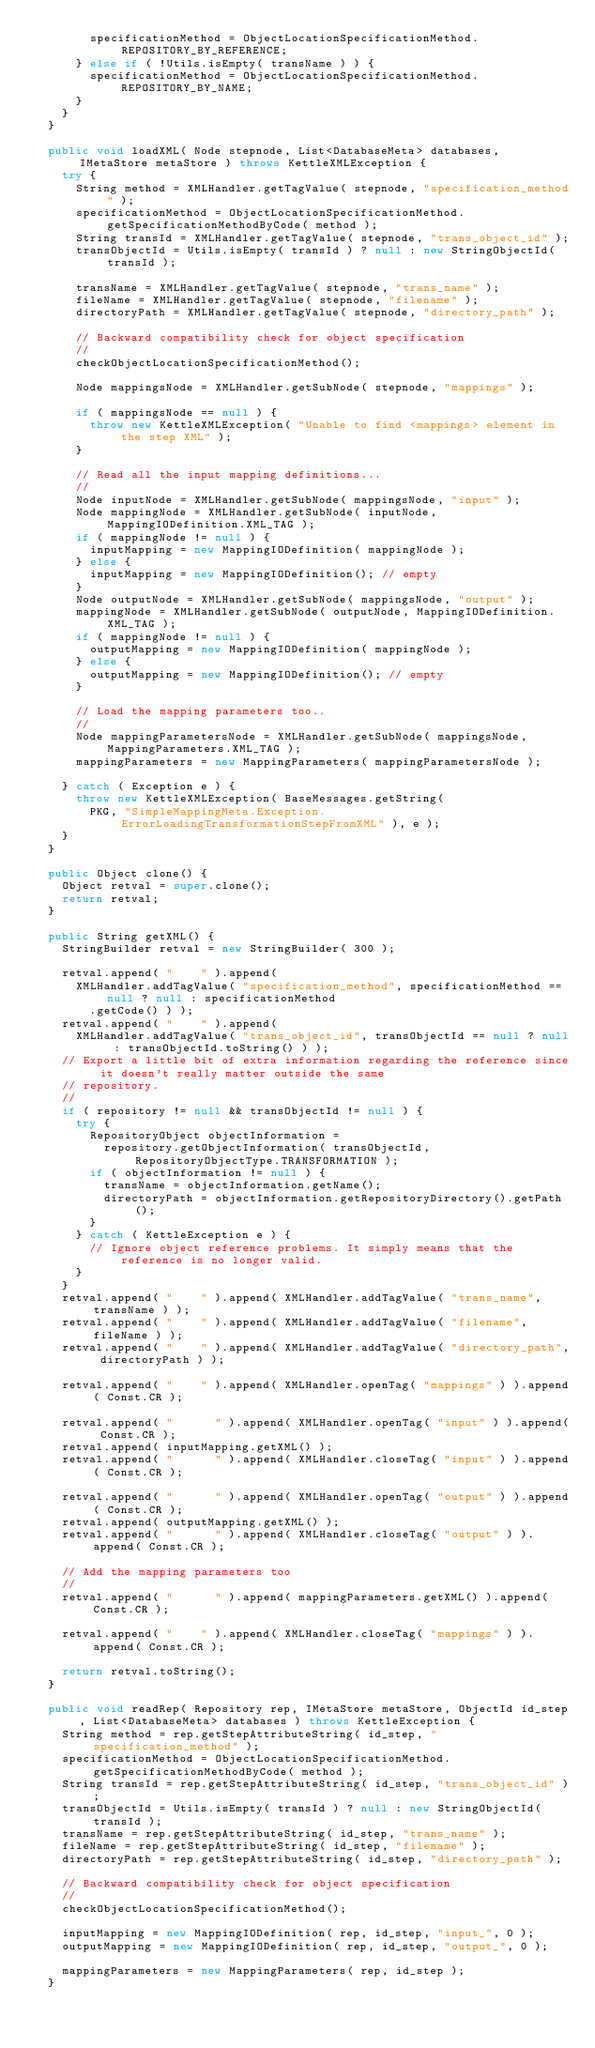Convert code to text. <code><loc_0><loc_0><loc_500><loc_500><_Java_>        specificationMethod = ObjectLocationSpecificationMethod.REPOSITORY_BY_REFERENCE;
      } else if ( !Utils.isEmpty( transName ) ) {
        specificationMethod = ObjectLocationSpecificationMethod.REPOSITORY_BY_NAME;
      }
    }
  }

  public void loadXML( Node stepnode, List<DatabaseMeta> databases, IMetaStore metaStore ) throws KettleXMLException {
    try {
      String method = XMLHandler.getTagValue( stepnode, "specification_method" );
      specificationMethod = ObjectLocationSpecificationMethod.getSpecificationMethodByCode( method );
      String transId = XMLHandler.getTagValue( stepnode, "trans_object_id" );
      transObjectId = Utils.isEmpty( transId ) ? null : new StringObjectId( transId );

      transName = XMLHandler.getTagValue( stepnode, "trans_name" );
      fileName = XMLHandler.getTagValue( stepnode, "filename" );
      directoryPath = XMLHandler.getTagValue( stepnode, "directory_path" );

      // Backward compatibility check for object specification
      //
      checkObjectLocationSpecificationMethod();

      Node mappingsNode = XMLHandler.getSubNode( stepnode, "mappings" );

      if ( mappingsNode == null ) {
        throw new KettleXMLException( "Unable to find <mappings> element in the step XML" );
      }

      // Read all the input mapping definitions...
      //
      Node inputNode = XMLHandler.getSubNode( mappingsNode, "input" );
      Node mappingNode = XMLHandler.getSubNode( inputNode, MappingIODefinition.XML_TAG );
      if ( mappingNode != null ) {
        inputMapping = new MappingIODefinition( mappingNode );
      } else {
        inputMapping = new MappingIODefinition(); // empty
      }
      Node outputNode = XMLHandler.getSubNode( mappingsNode, "output" );
      mappingNode = XMLHandler.getSubNode( outputNode, MappingIODefinition.XML_TAG );
      if ( mappingNode != null ) {
        outputMapping = new MappingIODefinition( mappingNode );
      } else {
        outputMapping = new MappingIODefinition(); // empty
      }

      // Load the mapping parameters too..
      //
      Node mappingParametersNode = XMLHandler.getSubNode( mappingsNode, MappingParameters.XML_TAG );
      mappingParameters = new MappingParameters( mappingParametersNode );

    } catch ( Exception e ) {
      throw new KettleXMLException( BaseMessages.getString(
        PKG, "SimpleMappingMeta.Exception.ErrorLoadingTransformationStepFromXML" ), e );
    }
  }

  public Object clone() {
    Object retval = super.clone();
    return retval;
  }

  public String getXML() {
    StringBuilder retval = new StringBuilder( 300 );

    retval.append( "    " ).append(
      XMLHandler.addTagValue( "specification_method", specificationMethod == null ? null : specificationMethod
        .getCode() ) );
    retval.append( "    " ).append(
      XMLHandler.addTagValue( "trans_object_id", transObjectId == null ? null : transObjectId.toString() ) );
    // Export a little bit of extra information regarding the reference since it doesn't really matter outside the same
    // repository.
    //
    if ( repository != null && transObjectId != null ) {
      try {
        RepositoryObject objectInformation =
          repository.getObjectInformation( transObjectId, RepositoryObjectType.TRANSFORMATION );
        if ( objectInformation != null ) {
          transName = objectInformation.getName();
          directoryPath = objectInformation.getRepositoryDirectory().getPath();
        }
      } catch ( KettleException e ) {
        // Ignore object reference problems. It simply means that the reference is no longer valid.
      }
    }
    retval.append( "    " ).append( XMLHandler.addTagValue( "trans_name", transName ) );
    retval.append( "    " ).append( XMLHandler.addTagValue( "filename", fileName ) );
    retval.append( "    " ).append( XMLHandler.addTagValue( "directory_path", directoryPath ) );

    retval.append( "    " ).append( XMLHandler.openTag( "mappings" ) ).append( Const.CR );

    retval.append( "      " ).append( XMLHandler.openTag( "input" ) ).append( Const.CR );
    retval.append( inputMapping.getXML() );
    retval.append( "      " ).append( XMLHandler.closeTag( "input" ) ).append( Const.CR );

    retval.append( "      " ).append( XMLHandler.openTag( "output" ) ).append( Const.CR );
    retval.append( outputMapping.getXML() );
    retval.append( "      " ).append( XMLHandler.closeTag( "output" ) ).append( Const.CR );

    // Add the mapping parameters too
    //
    retval.append( "      " ).append( mappingParameters.getXML() ).append( Const.CR );

    retval.append( "    " ).append( XMLHandler.closeTag( "mappings" ) ).append( Const.CR );

    return retval.toString();
  }

  public void readRep( Repository rep, IMetaStore metaStore, ObjectId id_step, List<DatabaseMeta> databases ) throws KettleException {
    String method = rep.getStepAttributeString( id_step, "specification_method" );
    specificationMethod = ObjectLocationSpecificationMethod.getSpecificationMethodByCode( method );
    String transId = rep.getStepAttributeString( id_step, "trans_object_id" );
    transObjectId = Utils.isEmpty( transId ) ? null : new StringObjectId( transId );
    transName = rep.getStepAttributeString( id_step, "trans_name" );
    fileName = rep.getStepAttributeString( id_step, "filename" );
    directoryPath = rep.getStepAttributeString( id_step, "directory_path" );

    // Backward compatibility check for object specification
    //
    checkObjectLocationSpecificationMethod();

    inputMapping = new MappingIODefinition( rep, id_step, "input_", 0 );
    outputMapping = new MappingIODefinition( rep, id_step, "output_", 0 );

    mappingParameters = new MappingParameters( rep, id_step );
  }
</code> 